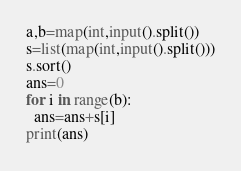Convert code to text. <code><loc_0><loc_0><loc_500><loc_500><_Python_>a,b=map(int,input().split())
s=list(map(int,input().split()))
s.sort()
ans=0
for i in range(b):
  ans=ans+s[i]
print(ans)  </code> 